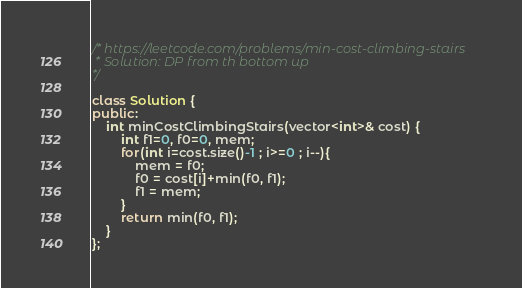<code> <loc_0><loc_0><loc_500><loc_500><_C++_>/* https://leetcode.com/problems/min-cost-climbing-stairs
 * Solution: DP from th bottom up
*/

class Solution {
public:
    int minCostClimbingStairs(vector<int>& cost) {
        int f1=0, f0=0, mem;
        for(int i=cost.size()-1 ; i>=0 ; i--){
            mem = f0;
            f0 = cost[i]+min(f0, f1);
            f1 = mem;
        }
        return min(f0, f1);
    }
};
</code> 